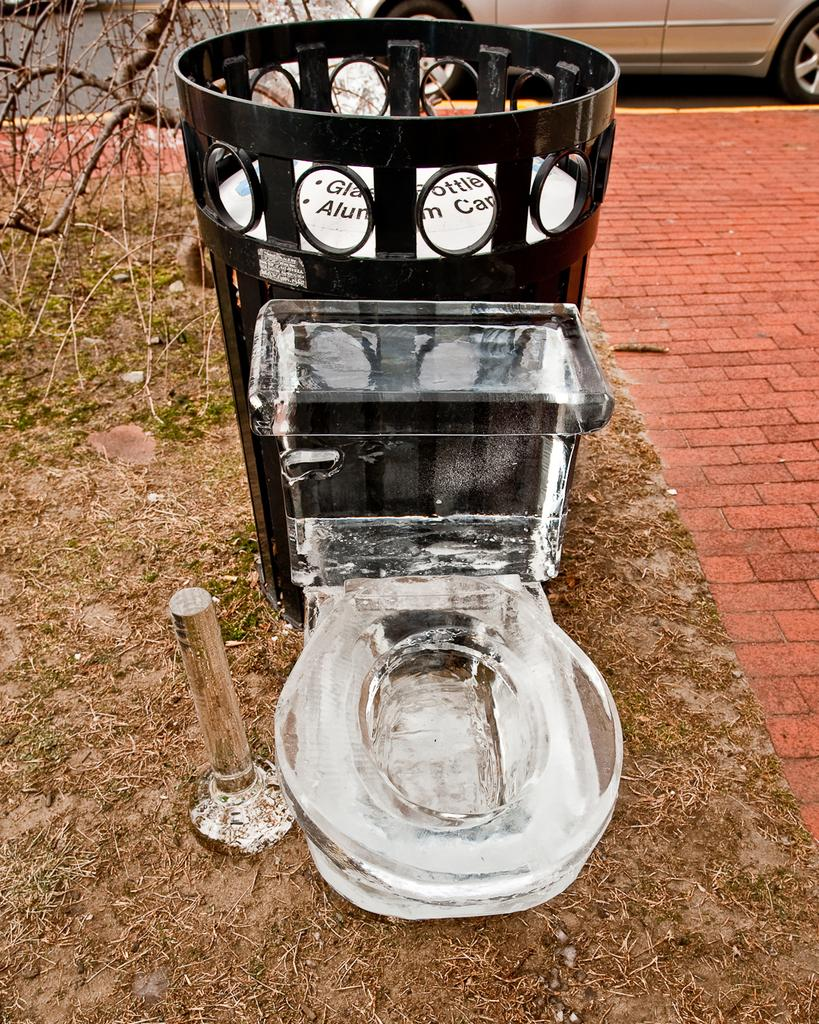Provide a one-sentence caption for the provided image. The can behind the toilet is intended for glass bottles and aluminum cans. 